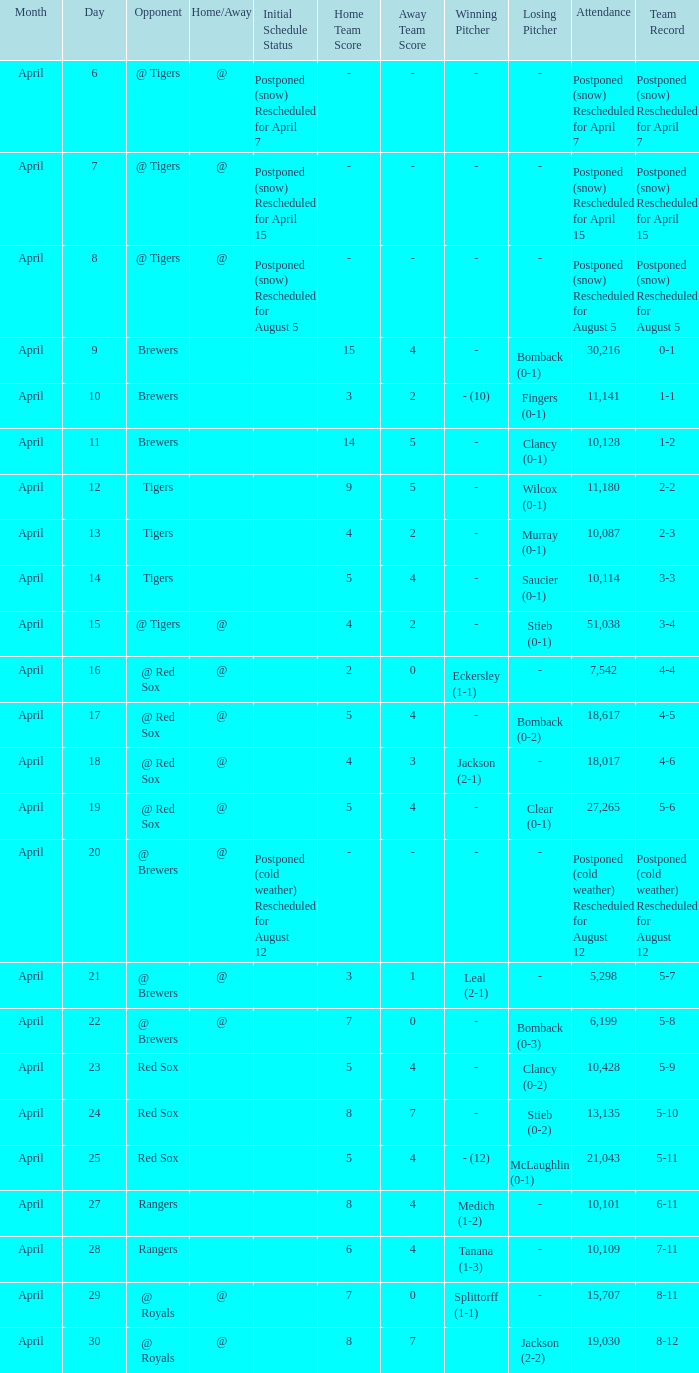Which record is dated April 8? Postponed (snow) Rescheduled for August 5. 